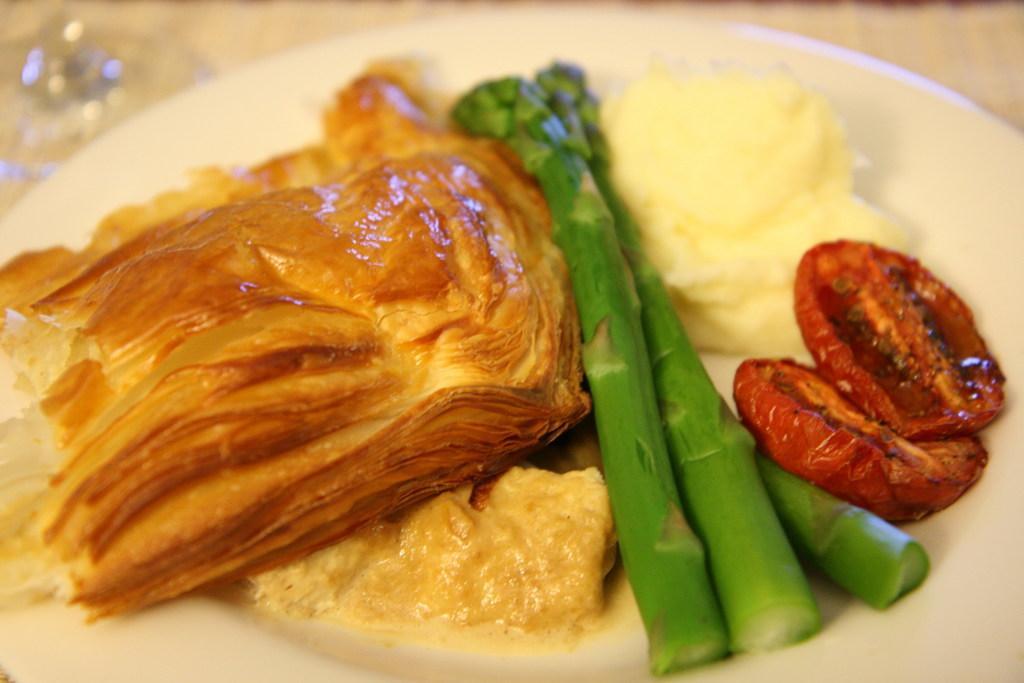Describe this image in one or two sentences. In this image I see the white plate on which there is food which is of brown, green, cream and red in color and I see that it is blurred in the background. 